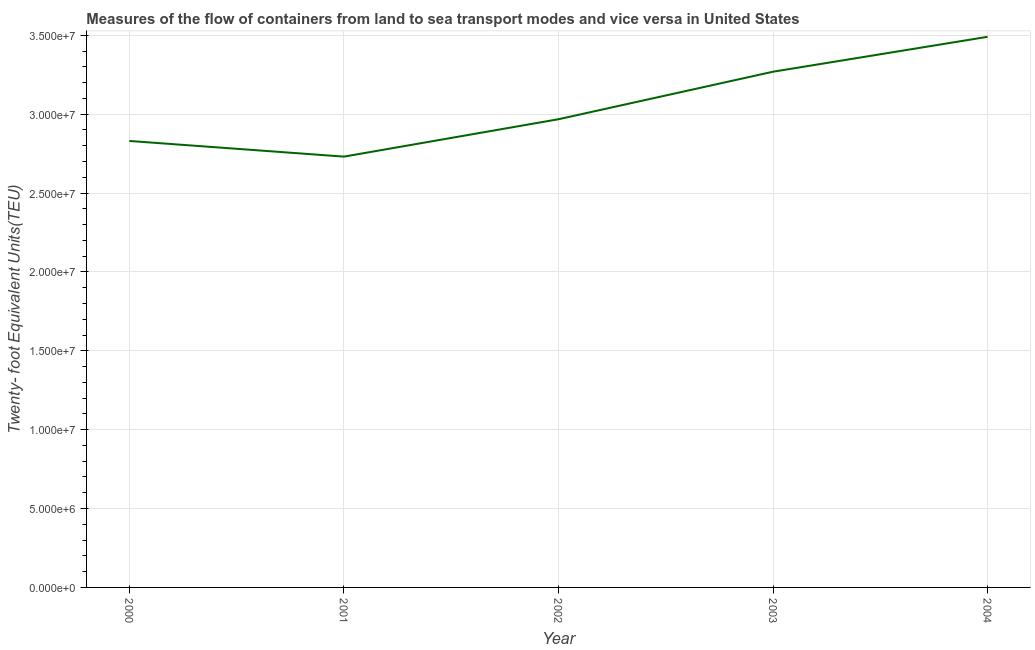What is the container port traffic in 2004?
Your answer should be very brief. 3.49e+07. Across all years, what is the maximum container port traffic?
Keep it short and to the point. 3.49e+07. Across all years, what is the minimum container port traffic?
Offer a terse response. 2.73e+07. What is the sum of the container port traffic?
Ensure brevity in your answer.  1.53e+08. What is the difference between the container port traffic in 2001 and 2003?
Offer a very short reply. -5.38e+06. What is the average container port traffic per year?
Make the answer very short. 3.06e+07. What is the median container port traffic?
Ensure brevity in your answer.  2.97e+07. In how many years, is the container port traffic greater than 21000000 TEU?
Your answer should be very brief. 5. What is the ratio of the container port traffic in 2003 to that in 2004?
Make the answer very short. 0.94. Is the difference between the container port traffic in 2001 and 2002 greater than the difference between any two years?
Give a very brief answer. No. What is the difference between the highest and the second highest container port traffic?
Make the answer very short. 2.21e+06. What is the difference between the highest and the lowest container port traffic?
Your answer should be compact. 7.59e+06. Does the container port traffic monotonically increase over the years?
Make the answer very short. No. How many years are there in the graph?
Make the answer very short. 5. What is the difference between two consecutive major ticks on the Y-axis?
Your answer should be compact. 5.00e+06. Are the values on the major ticks of Y-axis written in scientific E-notation?
Offer a very short reply. Yes. What is the title of the graph?
Your answer should be very brief. Measures of the flow of containers from land to sea transport modes and vice versa in United States. What is the label or title of the X-axis?
Offer a very short reply. Year. What is the label or title of the Y-axis?
Keep it short and to the point. Twenty- foot Equivalent Units(TEU). What is the Twenty- foot Equivalent Units(TEU) in 2000?
Give a very brief answer. 2.83e+07. What is the Twenty- foot Equivalent Units(TEU) in 2001?
Keep it short and to the point. 2.73e+07. What is the Twenty- foot Equivalent Units(TEU) of 2002?
Keep it short and to the point. 2.97e+07. What is the Twenty- foot Equivalent Units(TEU) in 2003?
Offer a very short reply. 3.27e+07. What is the Twenty- foot Equivalent Units(TEU) in 2004?
Offer a very short reply. 3.49e+07. What is the difference between the Twenty- foot Equivalent Units(TEU) in 2000 and 2001?
Give a very brief answer. 9.92e+05. What is the difference between the Twenty- foot Equivalent Units(TEU) in 2000 and 2002?
Keep it short and to the point. -1.38e+06. What is the difference between the Twenty- foot Equivalent Units(TEU) in 2000 and 2003?
Your response must be concise. -4.39e+06. What is the difference between the Twenty- foot Equivalent Units(TEU) in 2000 and 2004?
Your response must be concise. -6.60e+06. What is the difference between the Twenty- foot Equivalent Units(TEU) in 2001 and 2002?
Provide a succinct answer. -2.37e+06. What is the difference between the Twenty- foot Equivalent Units(TEU) in 2001 and 2003?
Provide a short and direct response. -5.38e+06. What is the difference between the Twenty- foot Equivalent Units(TEU) in 2001 and 2004?
Your answer should be very brief. -7.59e+06. What is the difference between the Twenty- foot Equivalent Units(TEU) in 2002 and 2003?
Your answer should be very brief. -3.01e+06. What is the difference between the Twenty- foot Equivalent Units(TEU) in 2002 and 2004?
Provide a short and direct response. -5.22e+06. What is the difference between the Twenty- foot Equivalent Units(TEU) in 2003 and 2004?
Ensure brevity in your answer.  -2.21e+06. What is the ratio of the Twenty- foot Equivalent Units(TEU) in 2000 to that in 2001?
Ensure brevity in your answer.  1.04. What is the ratio of the Twenty- foot Equivalent Units(TEU) in 2000 to that in 2002?
Provide a short and direct response. 0.95. What is the ratio of the Twenty- foot Equivalent Units(TEU) in 2000 to that in 2003?
Your answer should be very brief. 0.87. What is the ratio of the Twenty- foot Equivalent Units(TEU) in 2000 to that in 2004?
Offer a very short reply. 0.81. What is the ratio of the Twenty- foot Equivalent Units(TEU) in 2001 to that in 2002?
Provide a short and direct response. 0.92. What is the ratio of the Twenty- foot Equivalent Units(TEU) in 2001 to that in 2003?
Offer a very short reply. 0.83. What is the ratio of the Twenty- foot Equivalent Units(TEU) in 2001 to that in 2004?
Make the answer very short. 0.78. What is the ratio of the Twenty- foot Equivalent Units(TEU) in 2002 to that in 2003?
Make the answer very short. 0.91. What is the ratio of the Twenty- foot Equivalent Units(TEU) in 2003 to that in 2004?
Provide a succinct answer. 0.94. 